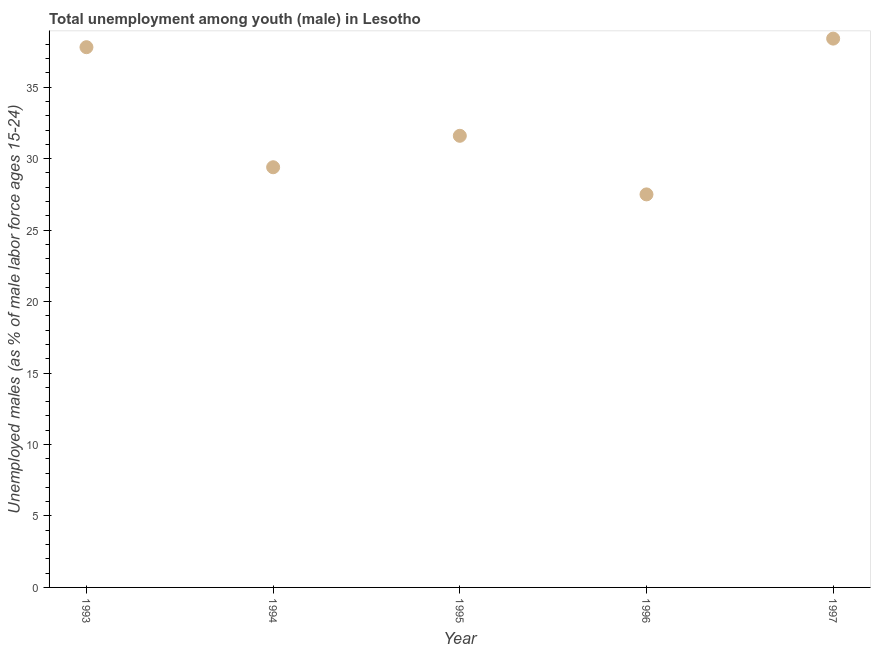What is the unemployed male youth population in 1994?
Make the answer very short. 29.4. Across all years, what is the maximum unemployed male youth population?
Offer a terse response. 38.4. Across all years, what is the minimum unemployed male youth population?
Your response must be concise. 27.5. In which year was the unemployed male youth population maximum?
Ensure brevity in your answer.  1997. What is the sum of the unemployed male youth population?
Your response must be concise. 164.7. What is the difference between the unemployed male youth population in 1996 and 1997?
Provide a succinct answer. -10.9. What is the average unemployed male youth population per year?
Your answer should be very brief. 32.94. What is the median unemployed male youth population?
Give a very brief answer. 31.6. What is the ratio of the unemployed male youth population in 1993 to that in 1994?
Offer a very short reply. 1.29. What is the difference between the highest and the second highest unemployed male youth population?
Your answer should be compact. 0.6. What is the difference between the highest and the lowest unemployed male youth population?
Make the answer very short. 10.9. Does the unemployed male youth population monotonically increase over the years?
Your answer should be compact. No. What is the difference between two consecutive major ticks on the Y-axis?
Keep it short and to the point. 5. Does the graph contain any zero values?
Your answer should be compact. No. Does the graph contain grids?
Your answer should be compact. No. What is the title of the graph?
Offer a terse response. Total unemployment among youth (male) in Lesotho. What is the label or title of the Y-axis?
Ensure brevity in your answer.  Unemployed males (as % of male labor force ages 15-24). What is the Unemployed males (as % of male labor force ages 15-24) in 1993?
Offer a terse response. 37.8. What is the Unemployed males (as % of male labor force ages 15-24) in 1994?
Ensure brevity in your answer.  29.4. What is the Unemployed males (as % of male labor force ages 15-24) in 1995?
Your response must be concise. 31.6. What is the Unemployed males (as % of male labor force ages 15-24) in 1997?
Give a very brief answer. 38.4. What is the difference between the Unemployed males (as % of male labor force ages 15-24) in 1993 and 1996?
Your answer should be compact. 10.3. What is the difference between the Unemployed males (as % of male labor force ages 15-24) in 1993 and 1997?
Ensure brevity in your answer.  -0.6. What is the difference between the Unemployed males (as % of male labor force ages 15-24) in 1994 and 1995?
Offer a very short reply. -2.2. What is the difference between the Unemployed males (as % of male labor force ages 15-24) in 1995 and 1996?
Your response must be concise. 4.1. What is the ratio of the Unemployed males (as % of male labor force ages 15-24) in 1993 to that in 1994?
Offer a very short reply. 1.29. What is the ratio of the Unemployed males (as % of male labor force ages 15-24) in 1993 to that in 1995?
Provide a short and direct response. 1.2. What is the ratio of the Unemployed males (as % of male labor force ages 15-24) in 1993 to that in 1996?
Keep it short and to the point. 1.38. What is the ratio of the Unemployed males (as % of male labor force ages 15-24) in 1993 to that in 1997?
Your answer should be compact. 0.98. What is the ratio of the Unemployed males (as % of male labor force ages 15-24) in 1994 to that in 1995?
Make the answer very short. 0.93. What is the ratio of the Unemployed males (as % of male labor force ages 15-24) in 1994 to that in 1996?
Your answer should be compact. 1.07. What is the ratio of the Unemployed males (as % of male labor force ages 15-24) in 1994 to that in 1997?
Your answer should be very brief. 0.77. What is the ratio of the Unemployed males (as % of male labor force ages 15-24) in 1995 to that in 1996?
Give a very brief answer. 1.15. What is the ratio of the Unemployed males (as % of male labor force ages 15-24) in 1995 to that in 1997?
Make the answer very short. 0.82. What is the ratio of the Unemployed males (as % of male labor force ages 15-24) in 1996 to that in 1997?
Your answer should be compact. 0.72. 